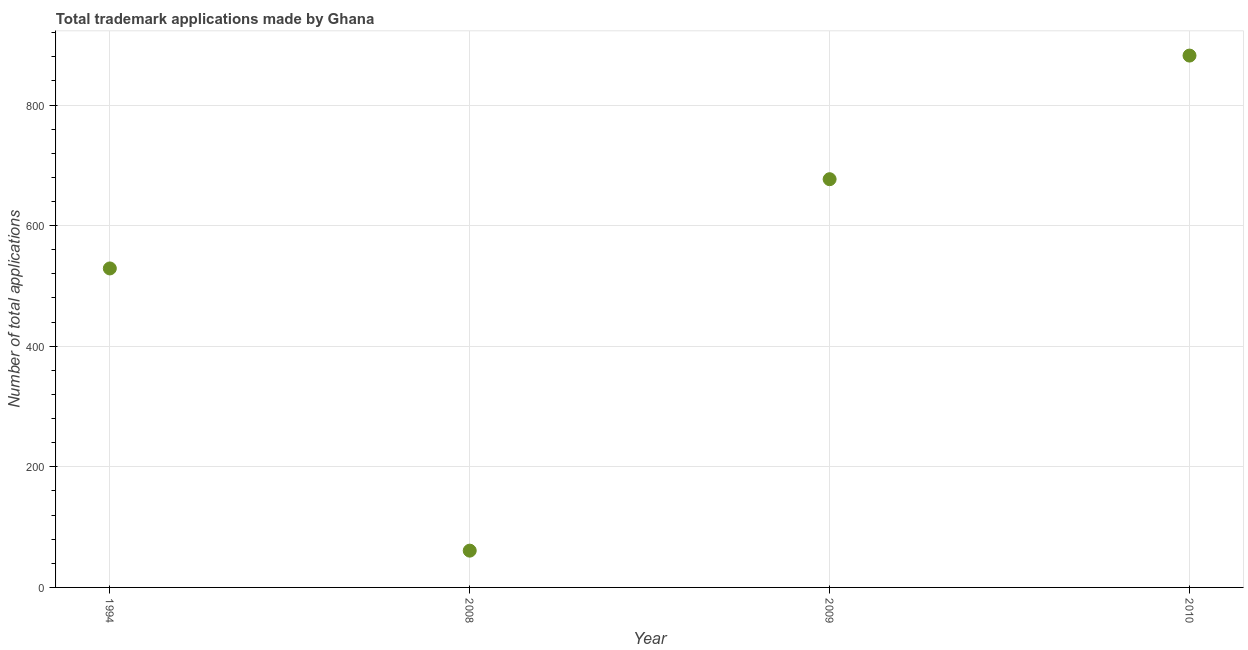What is the number of trademark applications in 2008?
Your response must be concise. 61. Across all years, what is the maximum number of trademark applications?
Make the answer very short. 882. Across all years, what is the minimum number of trademark applications?
Your answer should be very brief. 61. In which year was the number of trademark applications minimum?
Ensure brevity in your answer.  2008. What is the sum of the number of trademark applications?
Offer a very short reply. 2149. What is the difference between the number of trademark applications in 2008 and 2010?
Provide a short and direct response. -821. What is the average number of trademark applications per year?
Provide a short and direct response. 537.25. What is the median number of trademark applications?
Your answer should be compact. 603. In how many years, is the number of trademark applications greater than 560 ?
Your answer should be compact. 2. What is the ratio of the number of trademark applications in 2008 to that in 2009?
Your response must be concise. 0.09. Is the number of trademark applications in 1994 less than that in 2008?
Keep it short and to the point. No. What is the difference between the highest and the second highest number of trademark applications?
Ensure brevity in your answer.  205. What is the difference between the highest and the lowest number of trademark applications?
Your response must be concise. 821. Does the number of trademark applications monotonically increase over the years?
Offer a terse response. No. How many dotlines are there?
Keep it short and to the point. 1. How many years are there in the graph?
Make the answer very short. 4. Are the values on the major ticks of Y-axis written in scientific E-notation?
Your response must be concise. No. Does the graph contain any zero values?
Give a very brief answer. No. Does the graph contain grids?
Your answer should be very brief. Yes. What is the title of the graph?
Keep it short and to the point. Total trademark applications made by Ghana. What is the label or title of the X-axis?
Make the answer very short. Year. What is the label or title of the Y-axis?
Ensure brevity in your answer.  Number of total applications. What is the Number of total applications in 1994?
Your response must be concise. 529. What is the Number of total applications in 2009?
Give a very brief answer. 677. What is the Number of total applications in 2010?
Offer a terse response. 882. What is the difference between the Number of total applications in 1994 and 2008?
Your answer should be very brief. 468. What is the difference between the Number of total applications in 1994 and 2009?
Keep it short and to the point. -148. What is the difference between the Number of total applications in 1994 and 2010?
Make the answer very short. -353. What is the difference between the Number of total applications in 2008 and 2009?
Offer a terse response. -616. What is the difference between the Number of total applications in 2008 and 2010?
Provide a succinct answer. -821. What is the difference between the Number of total applications in 2009 and 2010?
Keep it short and to the point. -205. What is the ratio of the Number of total applications in 1994 to that in 2008?
Your response must be concise. 8.67. What is the ratio of the Number of total applications in 1994 to that in 2009?
Your response must be concise. 0.78. What is the ratio of the Number of total applications in 2008 to that in 2009?
Provide a succinct answer. 0.09. What is the ratio of the Number of total applications in 2008 to that in 2010?
Provide a short and direct response. 0.07. What is the ratio of the Number of total applications in 2009 to that in 2010?
Your answer should be very brief. 0.77. 